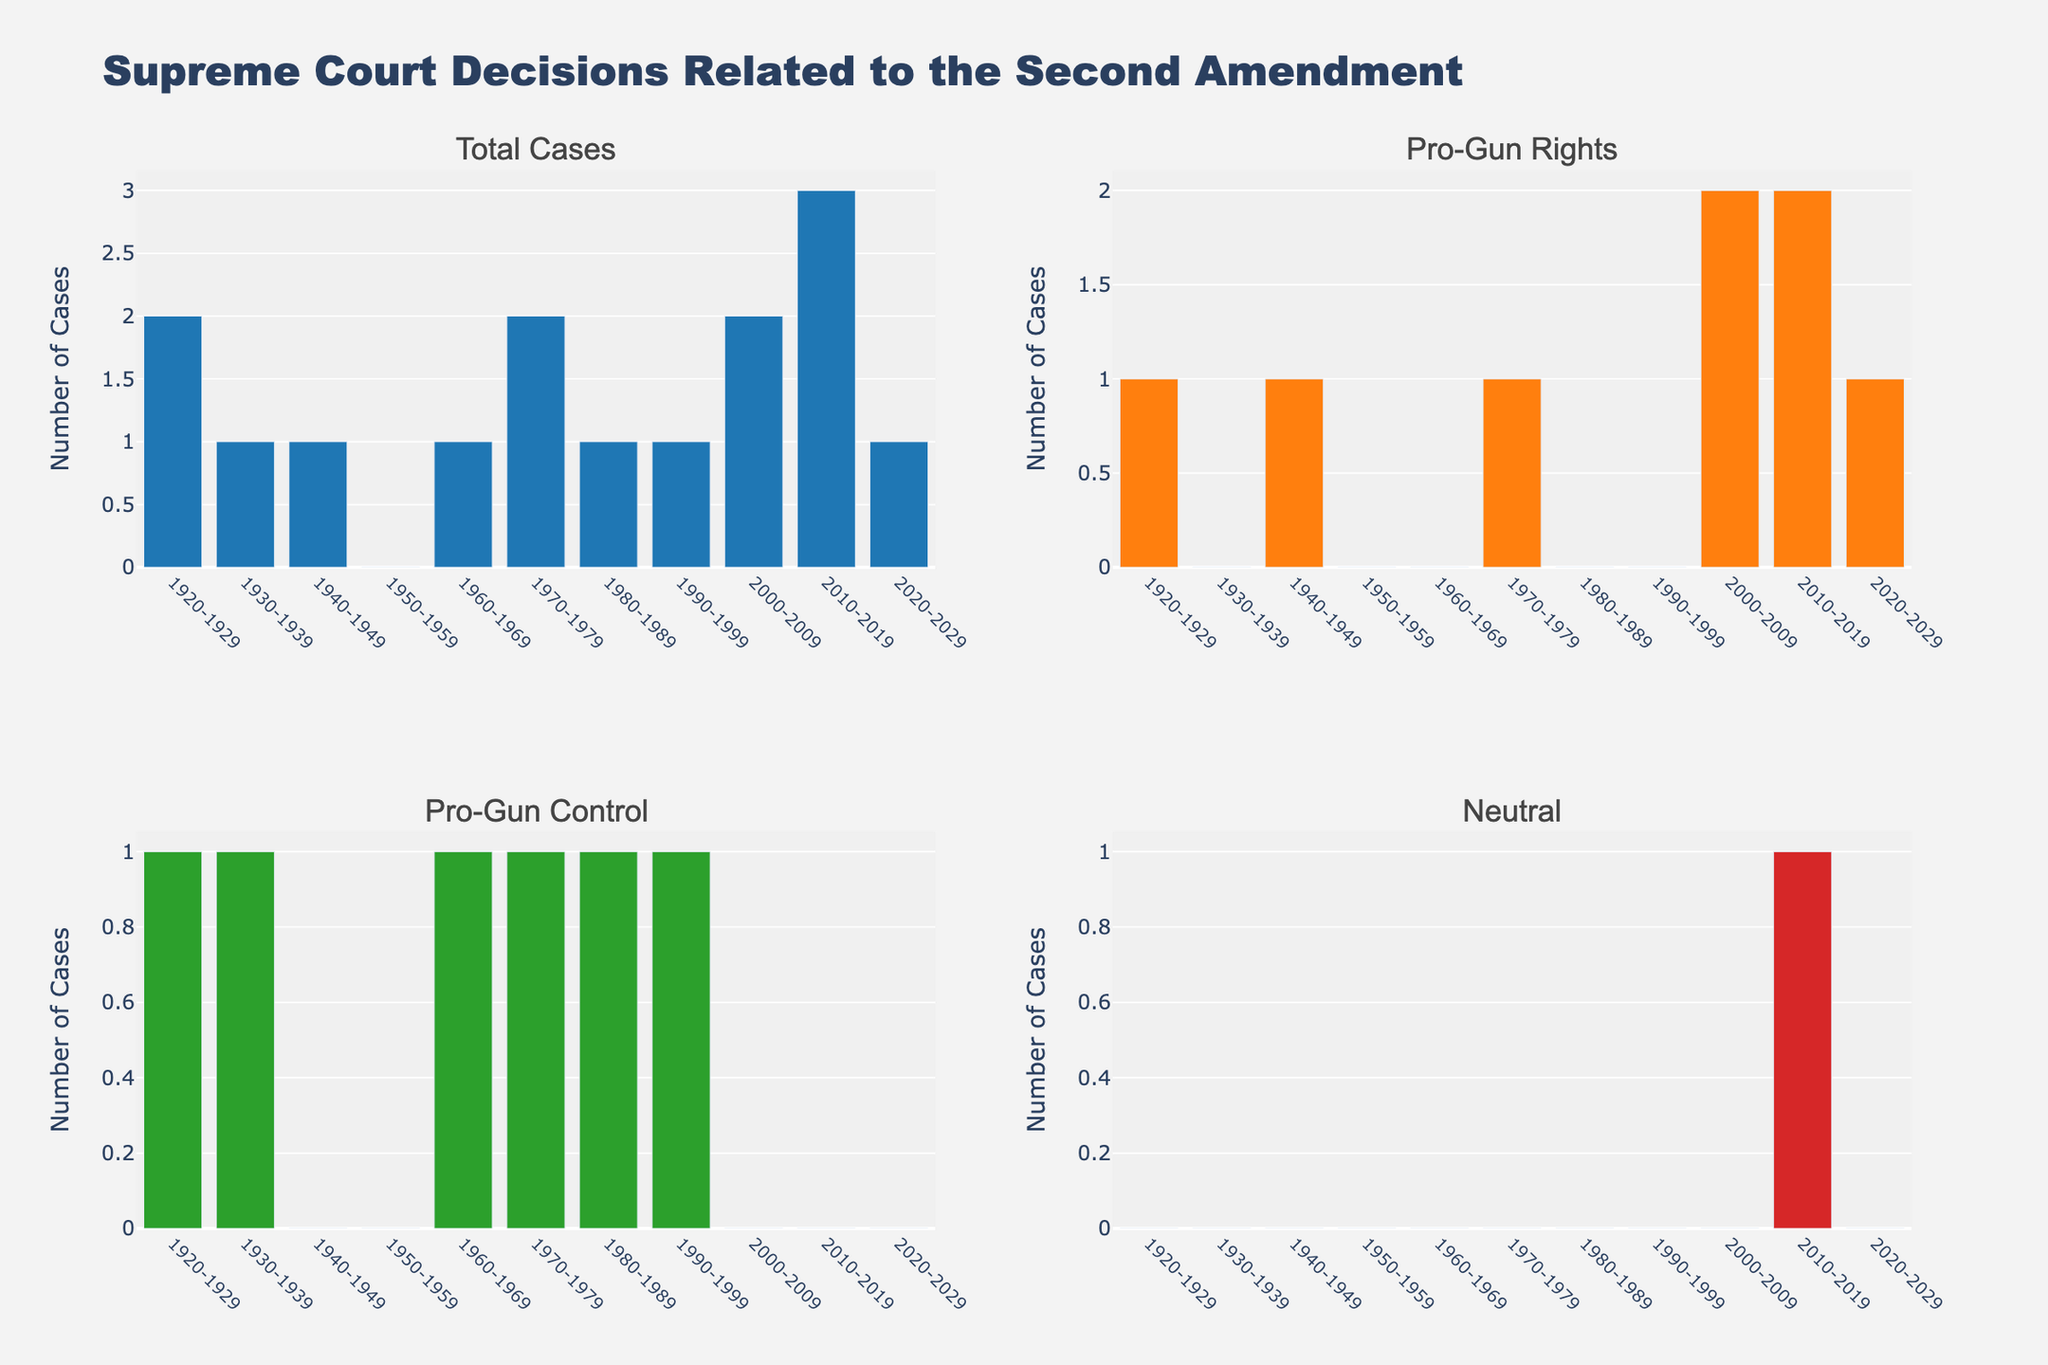How many Supreme Court cases related to the Second Amendment were there in the decade 2010-2019? We need to look at the bar labeled "2010-2019" in the "Total Cases" subplot. The height of this bar shows the number of cases.
Answer: 3 Which decade had the highest number of Supreme Court cases related to the Second Amendment? We compare the heights of the bars in the "Total Cases" subplot. The tallest bar indicates the decade with the highest number of cases, which is 2010-2019.
Answer: 2010-2019 In which decade did the Supreme Court decide an equal number of Pro-Gun Rights and Pro-Gun Control cases? We look at the subplots "Pro-Gun Rights" and "Pro-Gun Control" to find the decade(s) where the bars are of equal height. This occurs in the decades 1920-1929 and 1970-1979, where both have 1 case for each side.
Answer: 1920-1929, 1970-1979 What is the total number of Pro-Gun Rights decisions made from 2000-2029? We sum the values in the "Pro-Gun Rights" subplot for decades 2000-2009, 2010-2019, and 2020-2029. These values are 2, 2, and 1, respectively. Adding them gives 2 + 2 + 1 = 5.
Answer: 5 How many decades had zero Supreme Court cases related to the Second Amendment? We count the bars with height zero in the "Total Cases" subplot. There is only one such bar, in the decade 1950-1959.
Answer: 1 What is the difference in the number of Pro-Gun Control cases between the decades 2000-2009 and 2010-2019? We look at the heights of the bars for decades 2000-2009 and 2010-2019 in the "Pro-Gun Control" subplot. The heights are 0 and 0, respectively. The difference is 0 - 0 = 0.
Answer: 0 Which outcome had the most cases in the decade 2010-2019, and how many were there? We compare the heights of the bars for the decade 2010-2019 across all subplots ("Pro-Gun Rights," "Pro-Gun Control," and "Neutral"). The "Pro-Gun Rights" subplot has the tallest bar with a height of 2.
Answer: Pro-Gun Rights, 2 How many Neutral outcomes were there across all decades? We sum the heights of all the bars in the "Neutral" subplot. There is only one bar with a height of 1 in the decade 2010-2019.
Answer: 1 In which decade did the Supreme Court have its first Pro-Gun Rights decision related to the Second Amendment? We look at the "Pro-Gun Rights" subplot for the first non-zero height bar. The first such bar appears in the decade 1920-1929.
Answer: 1920-1929 